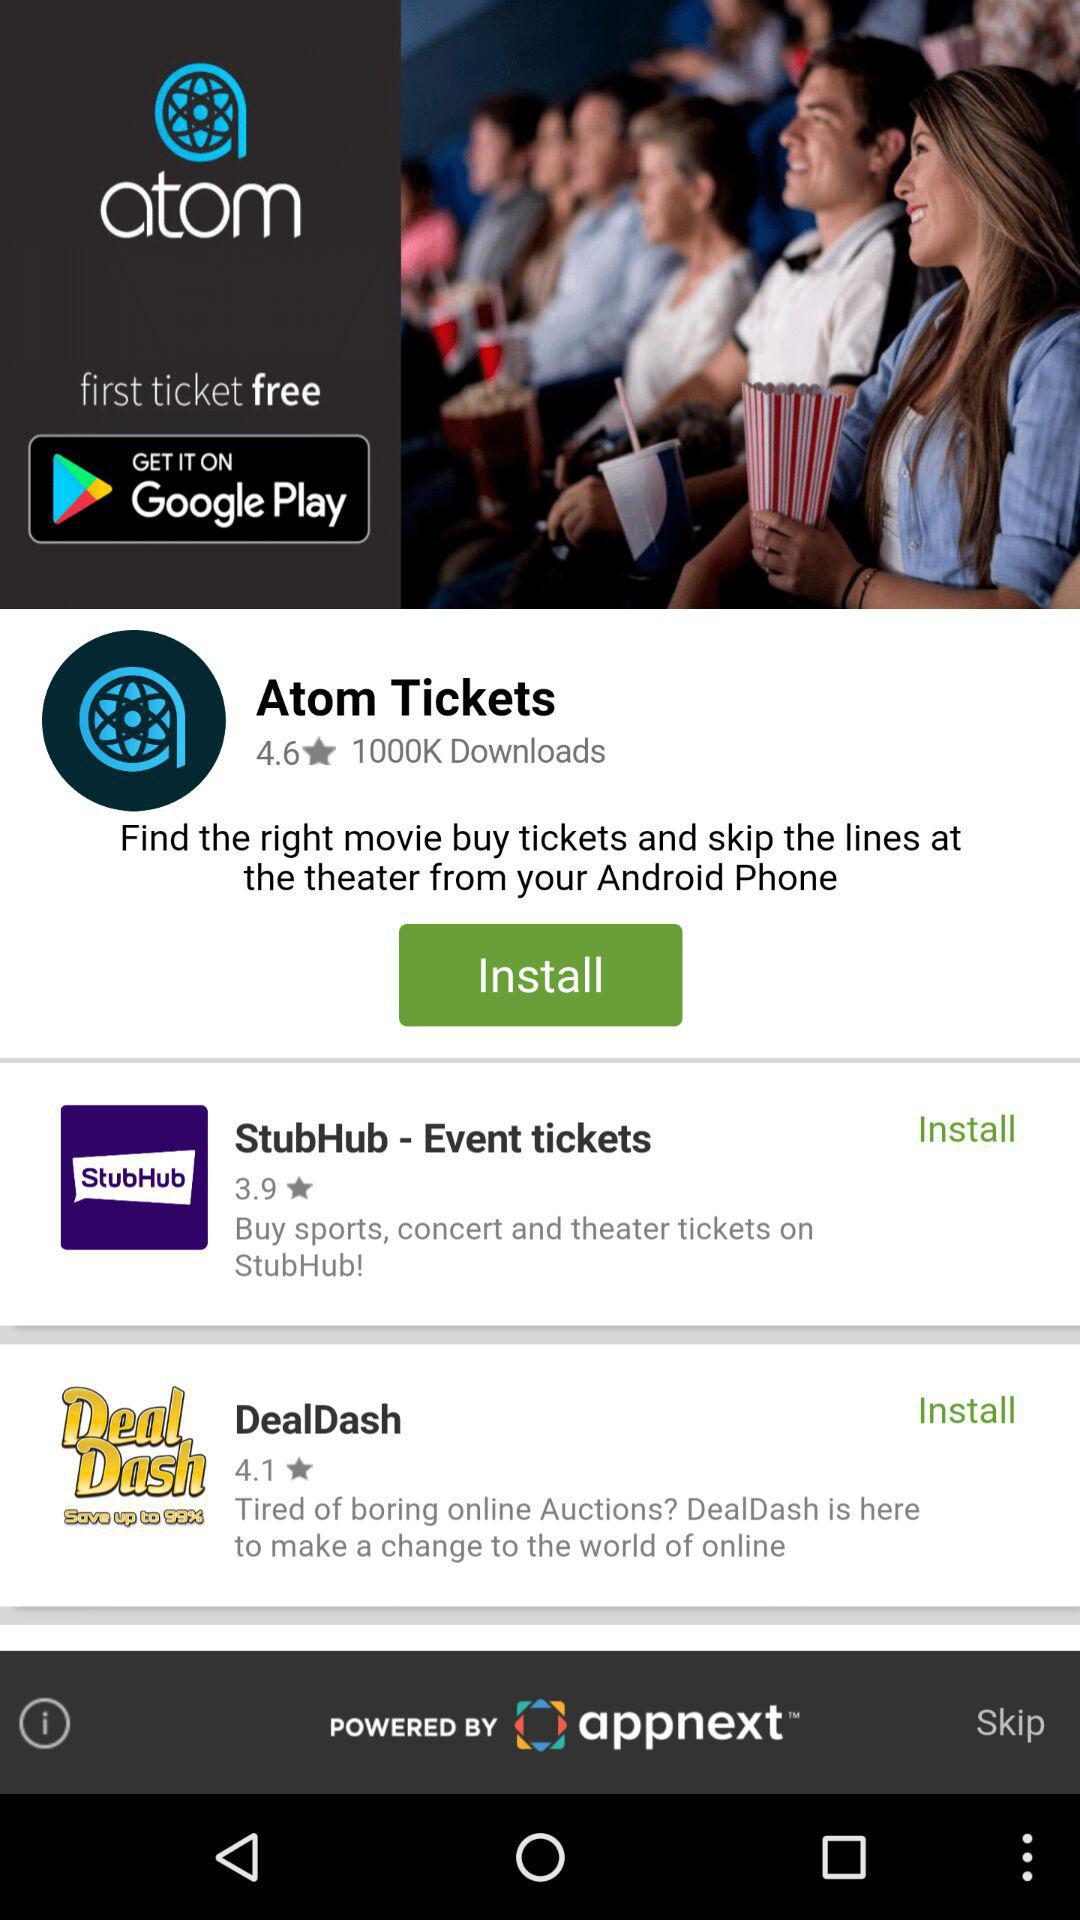What ticket is free? The free ticket is the first one. 